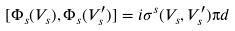<formula> <loc_0><loc_0><loc_500><loc_500>[ \Phi _ { s } ( V _ { s } ) , \Phi _ { s } ( V ^ { \prime } _ { s } ) ] = i \sigma ^ { s } ( V _ { s } , V ^ { \prime } _ { s } ) \i d</formula> 